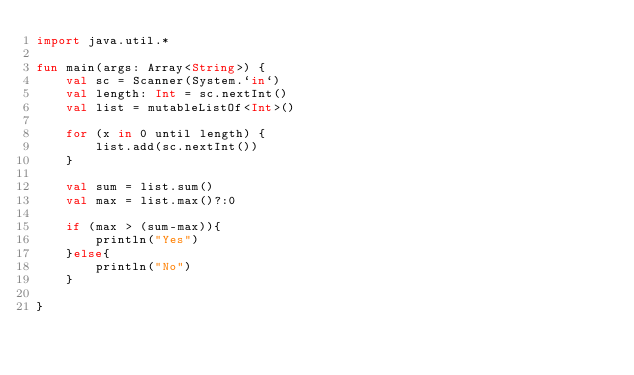<code> <loc_0><loc_0><loc_500><loc_500><_Kotlin_>import java.util.*

fun main(args: Array<String>) {
    val sc = Scanner(System.`in`)
    val length: Int = sc.nextInt()
    val list = mutableListOf<Int>()

    for (x in 0 until length) {
        list.add(sc.nextInt())
    }

    val sum = list.sum()
    val max = list.max()?:0

    if (max > (sum-max)){
        println("Yes")
    }else{
        println("No")
    }

}</code> 